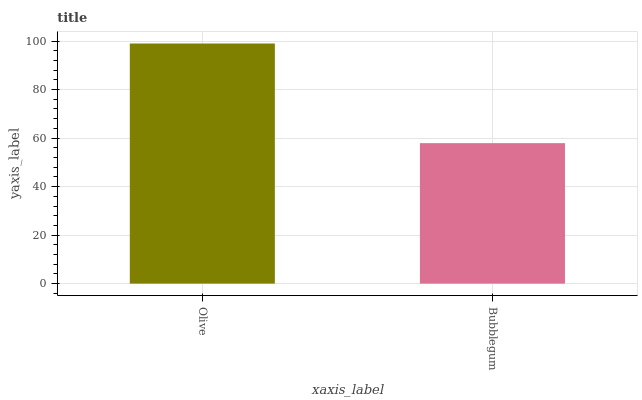Is Bubblegum the minimum?
Answer yes or no. Yes. Is Olive the maximum?
Answer yes or no. Yes. Is Bubblegum the maximum?
Answer yes or no. No. Is Olive greater than Bubblegum?
Answer yes or no. Yes. Is Bubblegum less than Olive?
Answer yes or no. Yes. Is Bubblegum greater than Olive?
Answer yes or no. No. Is Olive less than Bubblegum?
Answer yes or no. No. Is Olive the high median?
Answer yes or no. Yes. Is Bubblegum the low median?
Answer yes or no. Yes. Is Bubblegum the high median?
Answer yes or no. No. Is Olive the low median?
Answer yes or no. No. 